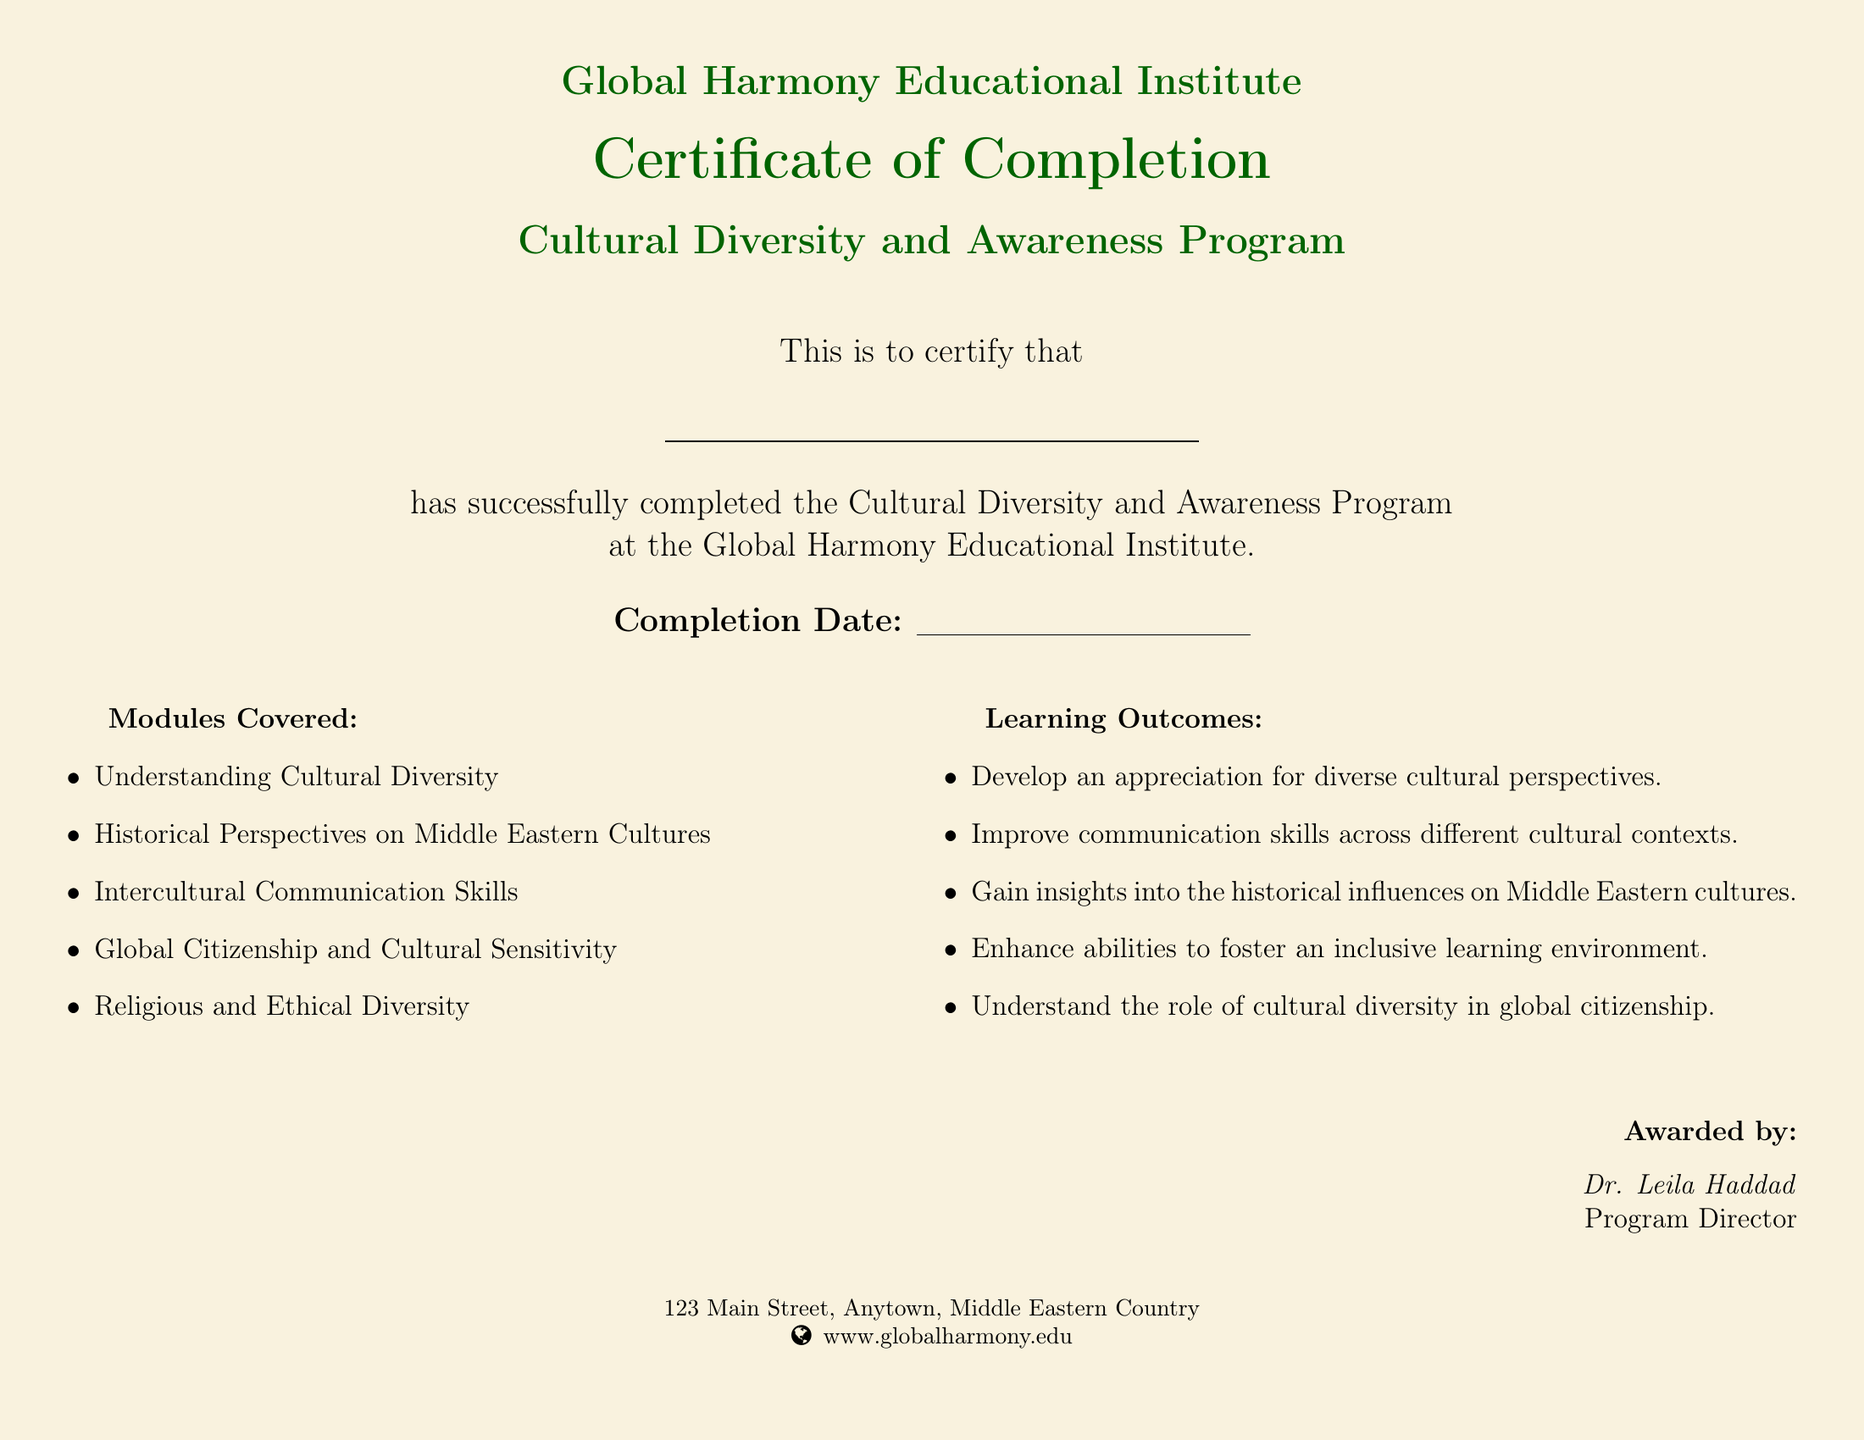What is the name of the institution? The name of the institution is prominently displayed at the top of the document as "Global Harmony Educational Institute."
Answer: Global Harmony Educational Institute What program did the student complete? The program that the student completed is identified as the "Cultural Diversity and Awareness Program."
Answer: Cultural Diversity and Awareness Program Who awarded the certification? The document states that the certification was awarded by Dr. Leila Haddad.
Answer: Dr. Leila Haddad What is the completion date format? The completion date format is represented as a blank line for the date, indicating that it will be filled in later.
Answer: Completion Date: (blank line) How many modules are covered in the program? The document lists five modules under "Modules Covered," indicating the number of modules covered in the program.
Answer: Five Name one module covered in the program. The document provides a list of modules, one of which is "Understanding Cultural Diversity."
Answer: Understanding Cultural Diversity What is one of the learning outcomes? One of the specified learning outcomes is "Develop an appreciation for diverse cultural perspectives."
Answer: Develop an appreciation for diverse cultural perspectives What is the color scheme of the document? The document features a gold color for the background and dark green for text highlights.
Answer: Gold and dark green What type of document is this? The document is recognized as a "Certificate of Completion."
Answer: Certificate of Completion 